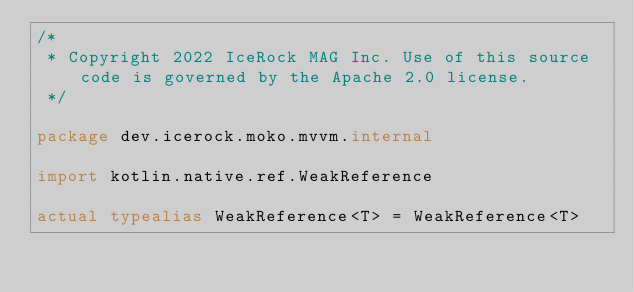Convert code to text. <code><loc_0><loc_0><loc_500><loc_500><_Kotlin_>/*
 * Copyright 2022 IceRock MAG Inc. Use of this source code is governed by the Apache 2.0 license.
 */

package dev.icerock.moko.mvvm.internal

import kotlin.native.ref.WeakReference

actual typealias WeakReference<T> = WeakReference<T>
</code> 